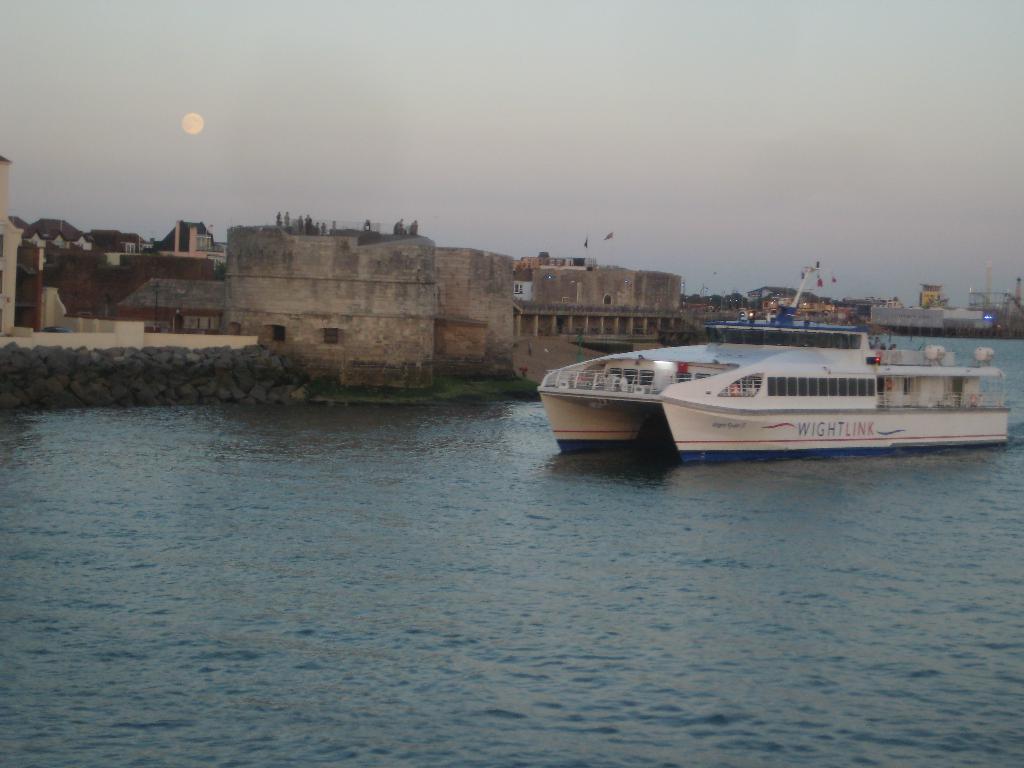Please provide a concise description of this image. In this image there is a ship on the river. In the background there are buildings and the sky. 